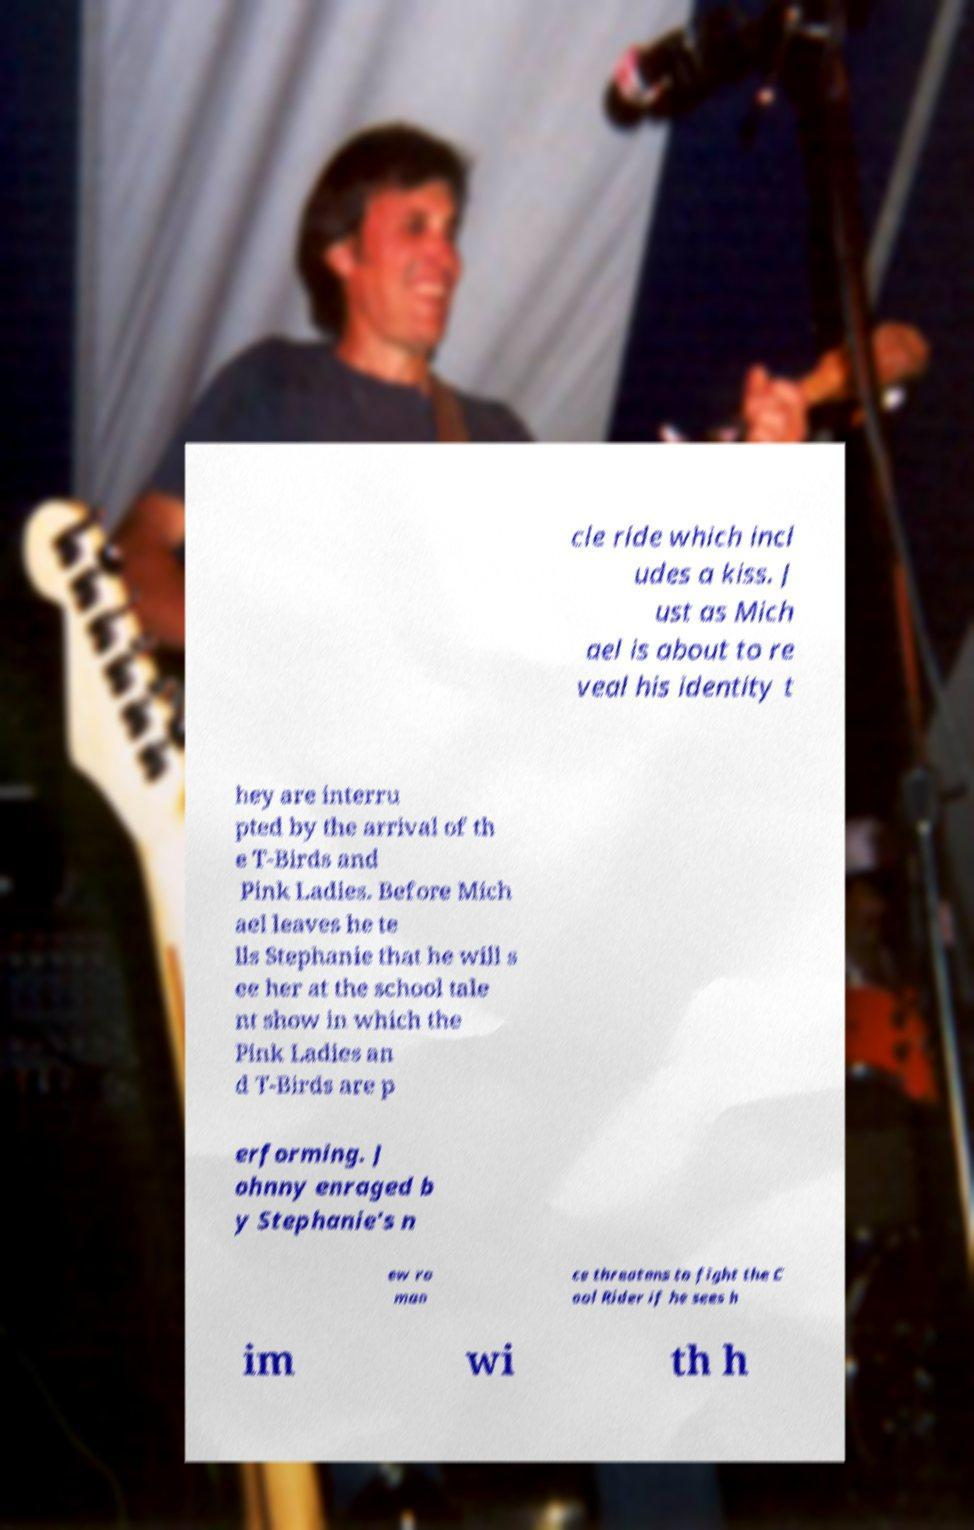Can you read and provide the text displayed in the image?This photo seems to have some interesting text. Can you extract and type it out for me? cle ride which incl udes a kiss. J ust as Mich ael is about to re veal his identity t hey are interru pted by the arrival of th e T-Birds and Pink Ladies. Before Mich ael leaves he te lls Stephanie that he will s ee her at the school tale nt show in which the Pink Ladies an d T-Birds are p erforming. J ohnny enraged b y Stephanie's n ew ro man ce threatens to fight the C ool Rider if he sees h im wi th h 